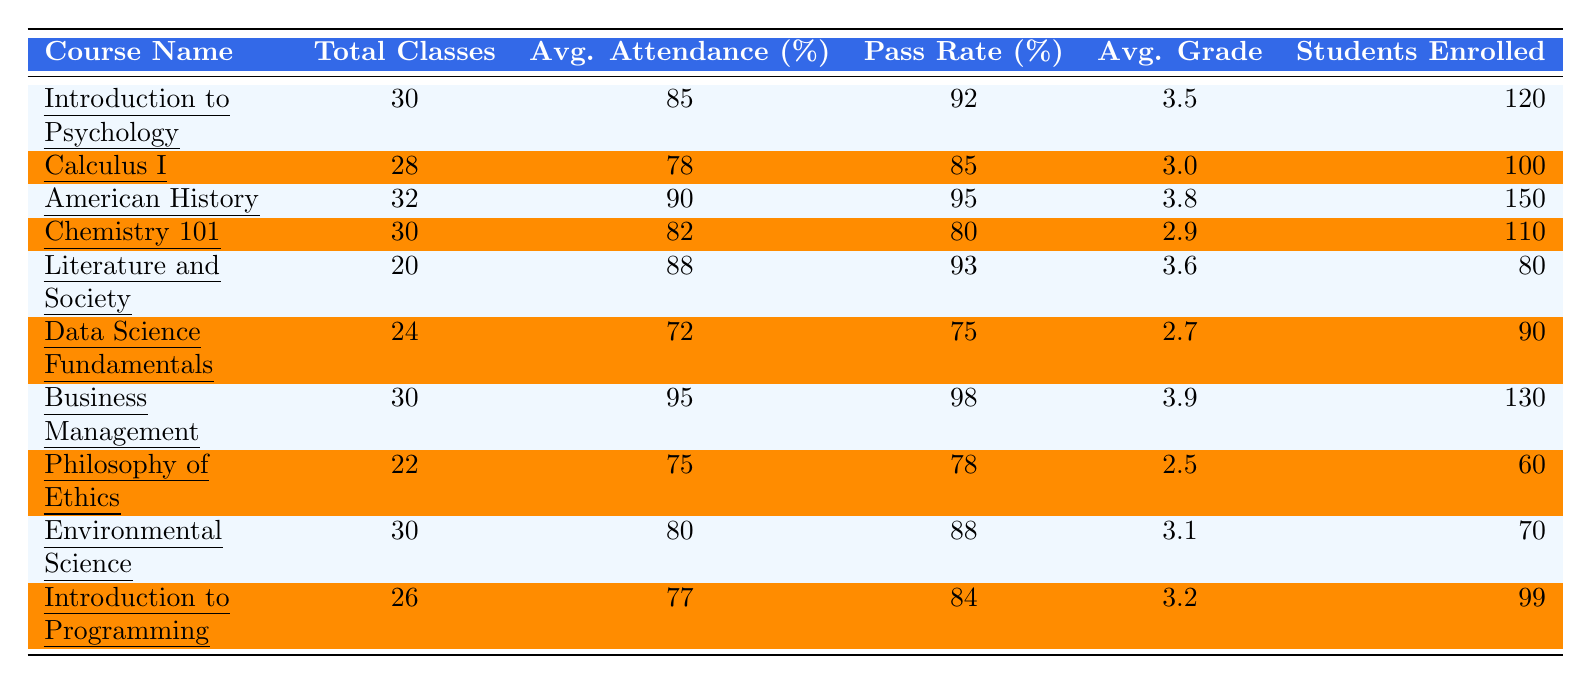What is the highest average attendance percentage among the courses? By looking at the table, we can see the average attendance percentages for each course. The highest is 95% for the course "Business Management."
Answer: 95% Which course has the lowest pass rate? In the table, we can examine the pass rates for each course. The lowest pass rate is 75%, found in "Data Science Fundamentals."
Answer: 75% How many students are enrolled in "American History"? Referring to the table, the enrollment number for "American History" is 150 students.
Answer: 150 Calculate the average grade for the courses with an average attendance above 80%. We identify courses with an average attendance over 80%, which are "Introduction to Psychology," "American History," "Literature and Society," "Business Management," and "Environmental Science." Their average grades are 3.5, 3.8, 3.6, 3.9, and 3.1, respectively. Adding these gives us 15.9. There are 5 courses, so the average grade is 15.9/5 = 3.18.
Answer: 3.18 Is there a course where the average grade is lower than the pass rate? By evaluating the table, we check courses with average grades and pass rates. For "Chemistry 101", the average grade is 2.9 and the pass rate is 80%. This is true for "Philosophy of Ethics" as well, where the average grade is 2.5 and the pass rate is 78%. Therefore, there are courses that meet this condition.
Answer: Yes What is the total number of students enrolled in courses with an average attendance below 80%? In the table, the courses with average attendance below 80% are "Calculus I" (100 students), "Data Science Fundamentals" (90 students), and "Philosophy of Ethics" (60 students). Adding these gives us 100 + 90 + 60 = 250.
Answer: 250 Find the difference between the highest and lowest average grades in the table. We find the highest average grade, which is 3.9 in "Business Management," and the lowest, which is 2.5 in "Philosophy of Ethics." The difference is 3.9 - 2.5 = 1.4.
Answer: 1.4 Which course has the highest number of classes and what is its corresponding pass rate? Looking through the table, "American History" has the highest number of classes at 32. The corresponding pass rate for this course is 95%.
Answer: 95% Identify all courses with both an average attendance percentage and average grade above the university averages of 80% and 3.0, respectively. By analyzing the table, we find that "Introduction to Psychology," "American History," "Literature and Society," and "Business Management" have both average attendance over 80% and grades above 3.0. All those courses qualify.
Answer: 4 courses 